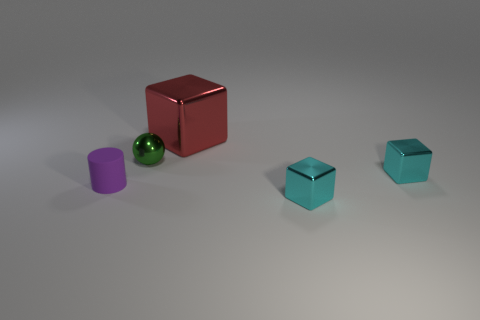Can you describe the colors and shapes of the objects I am seeing? Sure! The objects consist of a tiny purple cylinder, a small shiny green sphere, and two small cubes with a teal-like color, all set against a neutral gray background. Which is the largest object and what can you tell me about its surface? The largest object is the red cube, which has a reflective surface that could be described as 'metallic'. It is considerably larger in size compared to the other objects on display. 